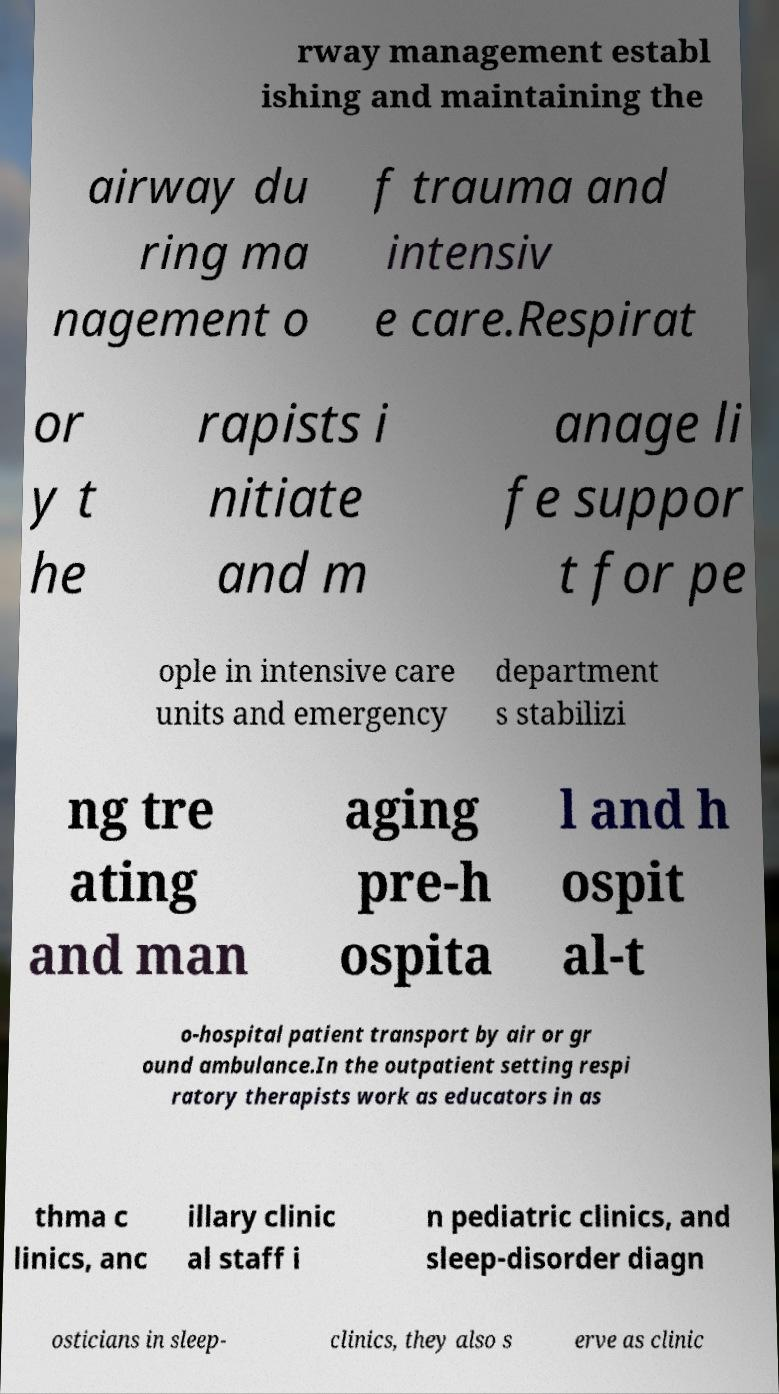Can you accurately transcribe the text from the provided image for me? rway management establ ishing and maintaining the airway du ring ma nagement o f trauma and intensiv e care.Respirat or y t he rapists i nitiate and m anage li fe suppor t for pe ople in intensive care units and emergency department s stabilizi ng tre ating and man aging pre-h ospita l and h ospit al-t o-hospital patient transport by air or gr ound ambulance.In the outpatient setting respi ratory therapists work as educators in as thma c linics, anc illary clinic al staff i n pediatric clinics, and sleep-disorder diagn osticians in sleep- clinics, they also s erve as clinic 